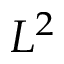Convert formula to latex. <formula><loc_0><loc_0><loc_500><loc_500>L ^ { 2 }</formula> 